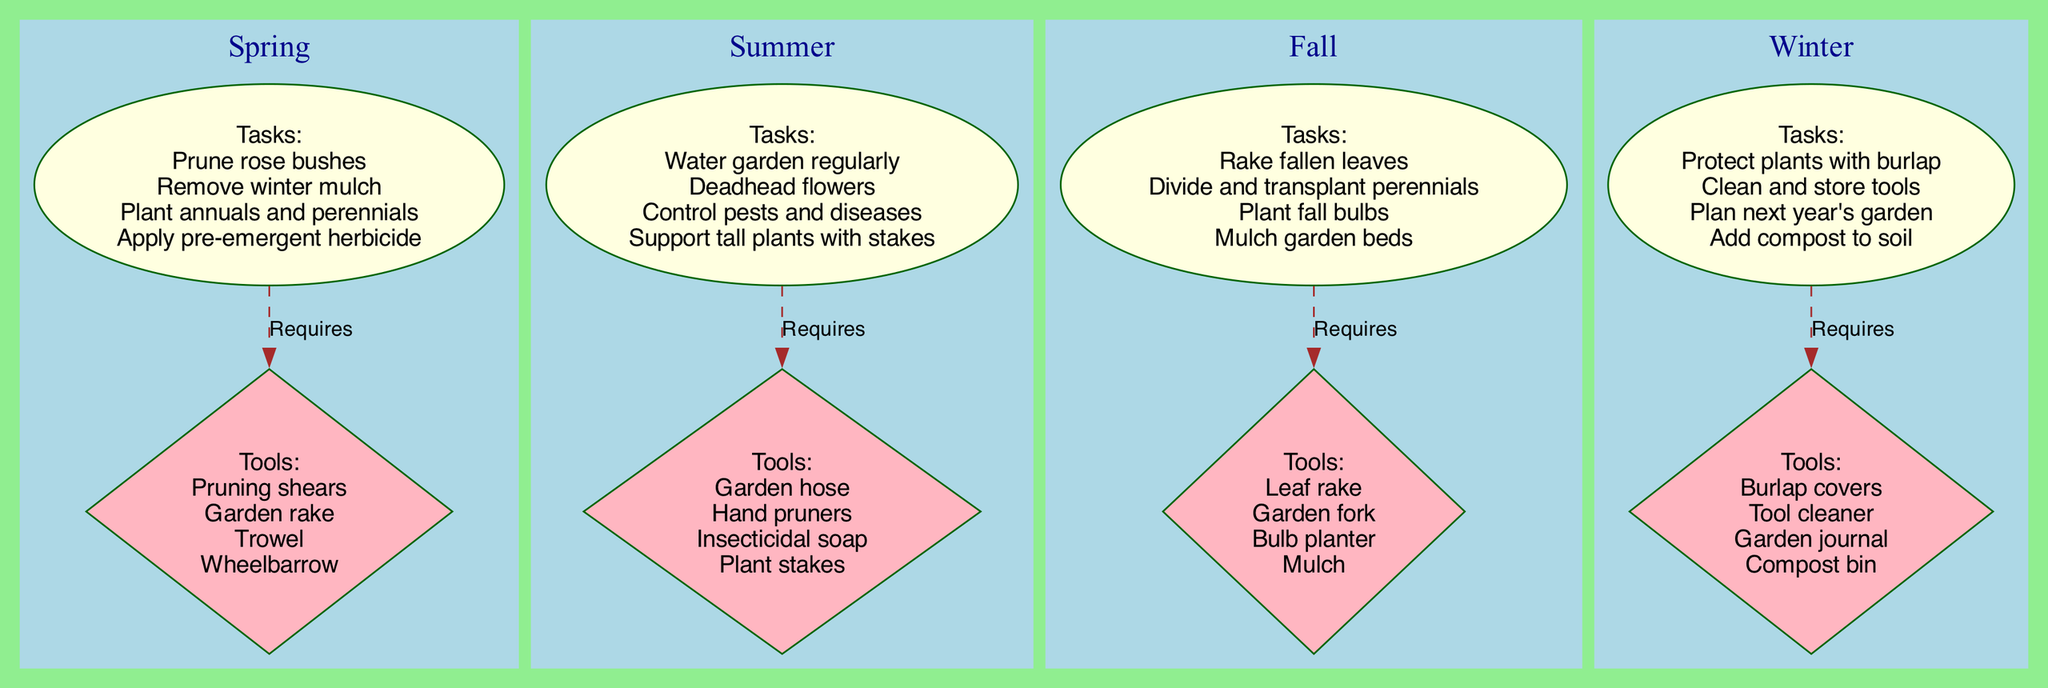What's the first task listed for Spring? According to the diagram, the first task under the Spring section is "Prune rose bushes." This is obtained by looking at the "Tasks" node within the Spring subgraph. It's the first item listed in the tasks.
Answer: Prune rose bushes How many tasks are listed for Fall? The Fall section contains four distinct tasks: "Rake fallen leaves," "Divide and transplant perennials," "Plant fall bulbs," and "Mulch garden beds." Therefore, by counting these tasks, we can determine that there are four tasks listed.
Answer: 4 What is the tool used for planting bulbs in the Fall? The tool identified for planting bulbs in the Fall is "Bulb planter." This can be found by checking the "Tools" node in the Fall subgraph, where it is specifically mentioned among the tools needed for that season.
Answer: Bulb planter Which season includes "Water garden regularly" as a task? The task "Water garden regularly" is found in the Summer section. By examining the Tasks node under Summer, we see this task explicitly listed.
Answer: Summer What relationship connects tasks and tools in each season? The relationship connecting the tasks and tools in each season is labeled as "Requires," which is indicated by the dashed edges that link the tasks nodes to the tools nodes for each season. It shows that the listed tools are needed to perform the corresponding tasks.
Answer: Requires Which tool is used for protecting plants in Winter? The tool used for protecting plants in Winter is "Burlap covers." This can be found by looking at the Tools node within the Winter section which specifies the tools required for that season.
Answer: Burlap covers What is the last task mentioned for Summer? The last task listed for the Summer season is "Support tall plants with stakes." By examining the tasks node under Summer, it is clear this is the final item mentioned in their tasks list.
Answer: Support tall plants with stakes List one tool used in Spring. One of the tools used in Spring is "Pruning shears." This item is found in the Tools node under the Spring section.
Answer: Pruning shears How many total tools are mentioned across all seasons? Counting the tools in each season, we have: Spring (4), Summer (4), Fall (4), and Winter (4), resulting in a total of 16 tools across all the seasons. This is calculated by cumulatively adding the tools from each Tools node in all seasonal subgraphs.
Answer: 16 